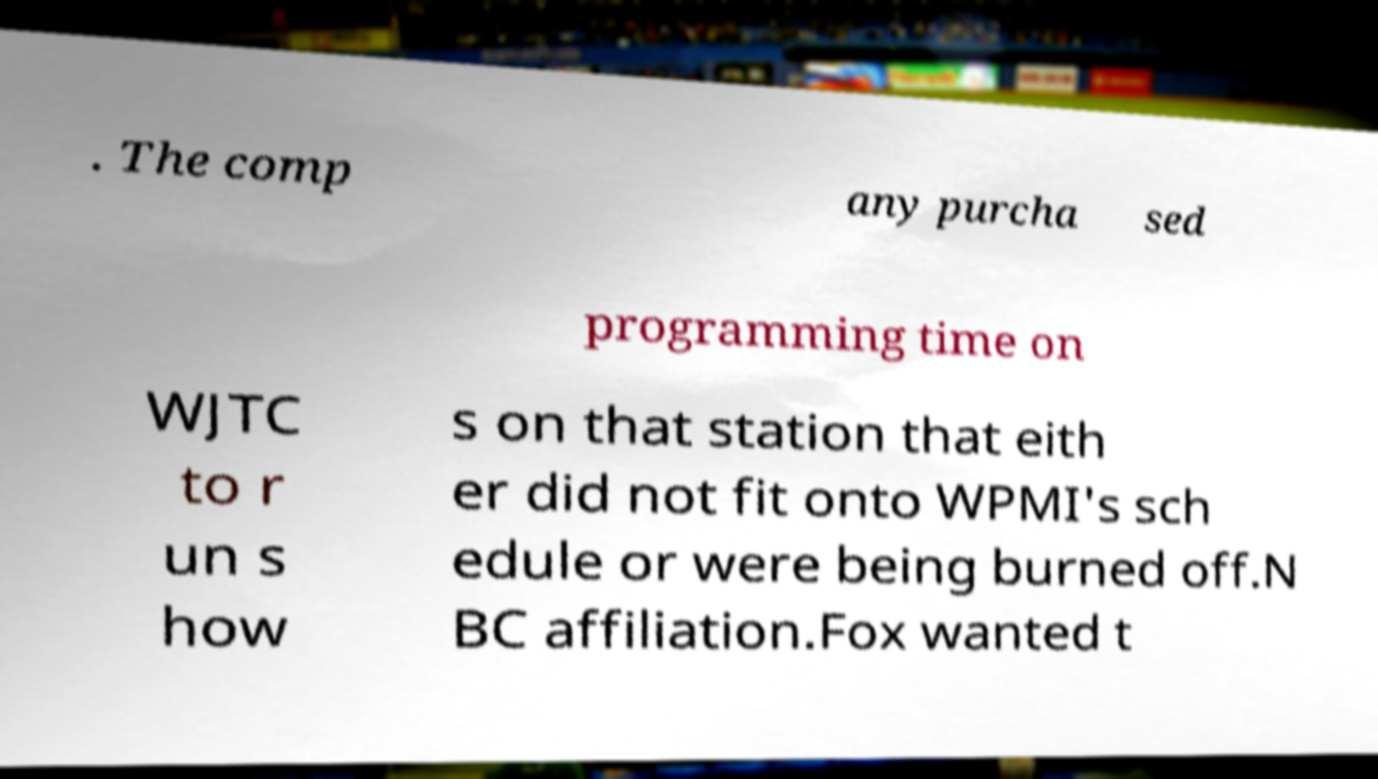Please identify and transcribe the text found in this image. . The comp any purcha sed programming time on WJTC to r un s how s on that station that eith er did not fit onto WPMI's sch edule or were being burned off.N BC affiliation.Fox wanted t 